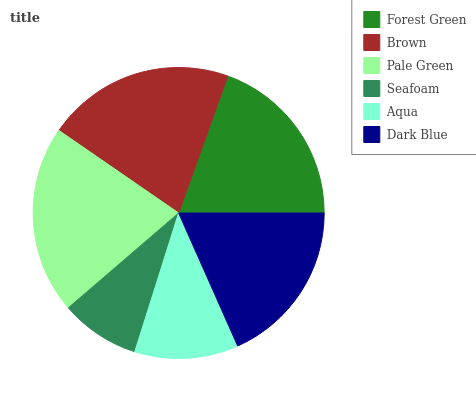Is Seafoam the minimum?
Answer yes or no. Yes. Is Pale Green the maximum?
Answer yes or no. Yes. Is Brown the minimum?
Answer yes or no. No. Is Brown the maximum?
Answer yes or no. No. Is Brown greater than Forest Green?
Answer yes or no. Yes. Is Forest Green less than Brown?
Answer yes or no. Yes. Is Forest Green greater than Brown?
Answer yes or no. No. Is Brown less than Forest Green?
Answer yes or no. No. Is Forest Green the high median?
Answer yes or no. Yes. Is Dark Blue the low median?
Answer yes or no. Yes. Is Brown the high median?
Answer yes or no. No. Is Seafoam the low median?
Answer yes or no. No. 